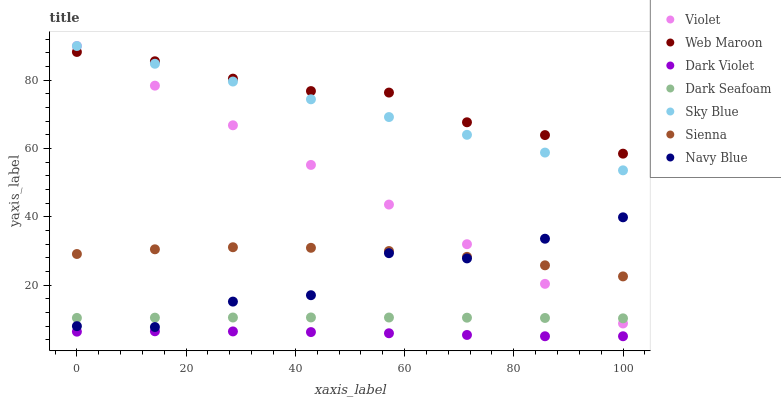Does Dark Violet have the minimum area under the curve?
Answer yes or no. Yes. Does Web Maroon have the maximum area under the curve?
Answer yes or no. Yes. Does Web Maroon have the minimum area under the curve?
Answer yes or no. No. Does Dark Violet have the maximum area under the curve?
Answer yes or no. No. Is Sky Blue the smoothest?
Answer yes or no. Yes. Is Navy Blue the roughest?
Answer yes or no. Yes. Is Web Maroon the smoothest?
Answer yes or no. No. Is Web Maroon the roughest?
Answer yes or no. No. Does Dark Violet have the lowest value?
Answer yes or no. Yes. Does Web Maroon have the lowest value?
Answer yes or no. No. Does Sky Blue have the highest value?
Answer yes or no. Yes. Does Web Maroon have the highest value?
Answer yes or no. No. Is Navy Blue less than Web Maroon?
Answer yes or no. Yes. Is Web Maroon greater than Navy Blue?
Answer yes or no. Yes. Does Sienna intersect Navy Blue?
Answer yes or no. Yes. Is Sienna less than Navy Blue?
Answer yes or no. No. Is Sienna greater than Navy Blue?
Answer yes or no. No. Does Navy Blue intersect Web Maroon?
Answer yes or no. No. 